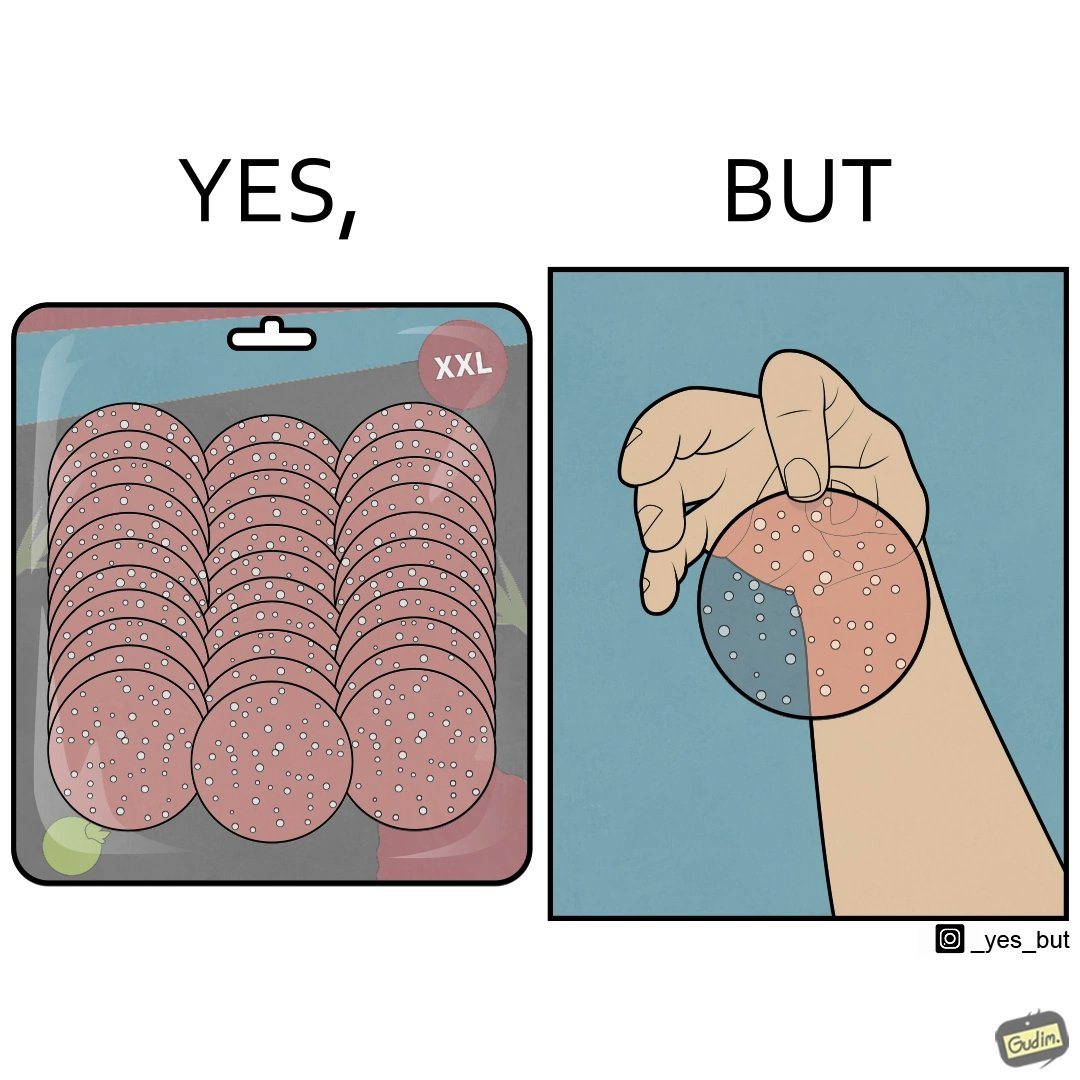Provide a description of this image. The irony in this image describes shrinkflation, which is when stores start selling big bags of products with less product in them. 